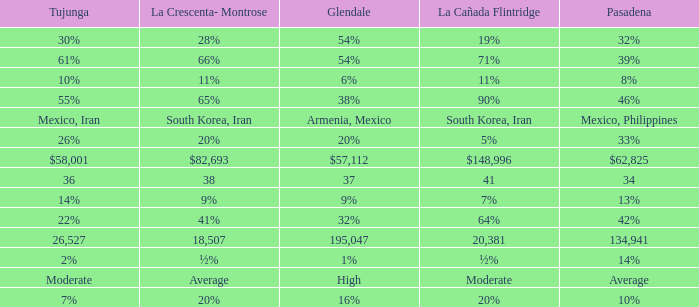When Tujunga is moderate, what is La Crescenta-Montrose? Average. 